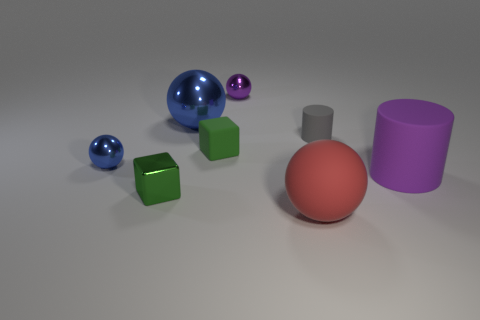How many blue spheres must be subtracted to get 1 blue spheres? 1 Subtract 2 spheres. How many spheres are left? 2 Subtract all large purple matte cubes. Subtract all red rubber objects. How many objects are left? 7 Add 7 purple cylinders. How many purple cylinders are left? 8 Add 8 purple cylinders. How many purple cylinders exist? 9 Subtract 1 gray cylinders. How many objects are left? 7 Subtract all blocks. How many objects are left? 6 Subtract all red spheres. Subtract all brown cubes. How many spheres are left? 3 